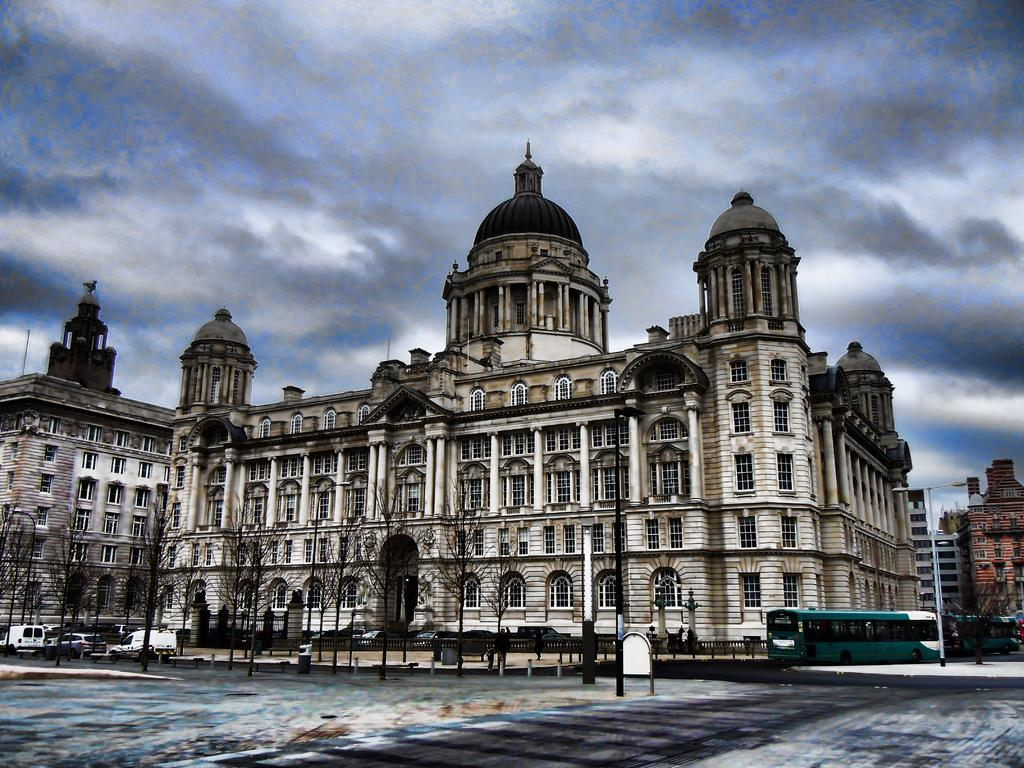What type of structure is visible in the image? There is a building with windows in the image. What else can be seen on the ground in the image? There are vehicles on the ground in the image. What object is present near the vehicles in the image? There is a street pole in the image. What type of vegetation is visible in the image? There is a group of trees in the image. What is the condition of the sky in the image? The sky is visible in the image and appears cloudy. What month is it in the image? The month cannot be determined from the image, as there is no information about the time of year or any seasonal indicators present. Can you see any chickens in the image? There are no chickens visible in the image. 